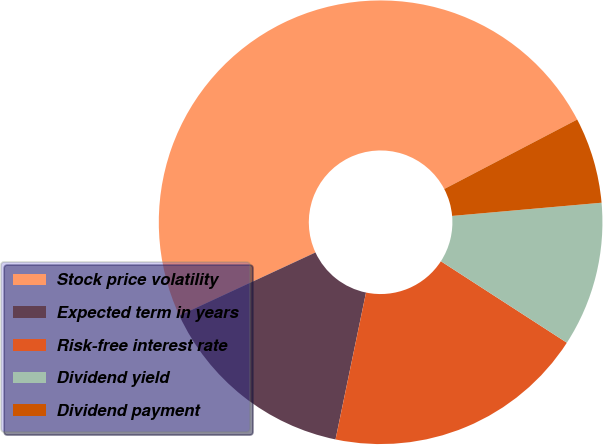<chart> <loc_0><loc_0><loc_500><loc_500><pie_chart><fcel>Stock price volatility<fcel>Expected term in years<fcel>Risk-free interest rate<fcel>Dividend yield<fcel>Dividend payment<nl><fcel>49.25%<fcel>14.83%<fcel>19.12%<fcel>10.54%<fcel>6.26%<nl></chart> 